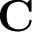Convert formula to latex. <formula><loc_0><loc_0><loc_500><loc_500>C</formula> 